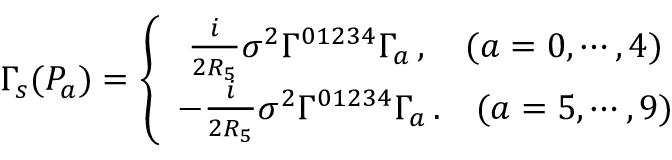Convert formula to latex. <formula><loc_0><loc_0><loc_500><loc_500>\Gamma _ { s } ( P _ { a } ) = \left \{ \begin{array} { c } { { \frac { i } { 2 R _ { 5 } } \sigma ^ { 2 } \Gamma ^ { 0 1 2 3 4 } \Gamma _ { a } \, , \quad ( a = 0 , \cdots , 4 ) } } \\ { { - \frac { i } { 2 R _ { 5 } } \sigma ^ { 2 } \Gamma ^ { 0 1 2 3 4 } \Gamma _ { a } \, . \quad ( a = 5 , \cdots , 9 ) } } \end{array}</formula> 